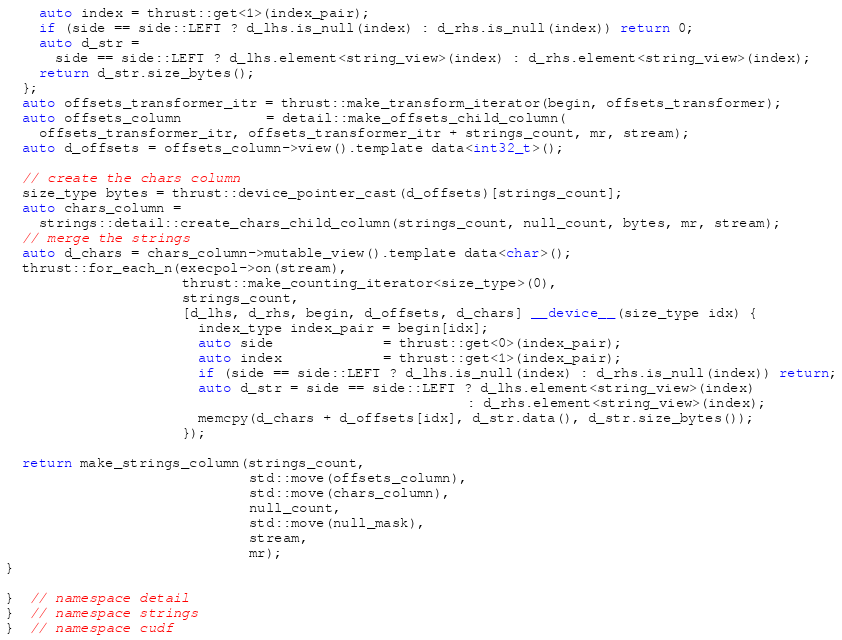Convert code to text. <code><loc_0><loc_0><loc_500><loc_500><_Cuda_>    auto index = thrust::get<1>(index_pair);
    if (side == side::LEFT ? d_lhs.is_null(index) : d_rhs.is_null(index)) return 0;
    auto d_str =
      side == side::LEFT ? d_lhs.element<string_view>(index) : d_rhs.element<string_view>(index);
    return d_str.size_bytes();
  };
  auto offsets_transformer_itr = thrust::make_transform_iterator(begin, offsets_transformer);
  auto offsets_column          = detail::make_offsets_child_column(
    offsets_transformer_itr, offsets_transformer_itr + strings_count, mr, stream);
  auto d_offsets = offsets_column->view().template data<int32_t>();

  // create the chars column
  size_type bytes = thrust::device_pointer_cast(d_offsets)[strings_count];
  auto chars_column =
    strings::detail::create_chars_child_column(strings_count, null_count, bytes, mr, stream);
  // merge the strings
  auto d_chars = chars_column->mutable_view().template data<char>();
  thrust::for_each_n(execpol->on(stream),
                     thrust::make_counting_iterator<size_type>(0),
                     strings_count,
                     [d_lhs, d_rhs, begin, d_offsets, d_chars] __device__(size_type idx) {
                       index_type index_pair = begin[idx];
                       auto side             = thrust::get<0>(index_pair);
                       auto index            = thrust::get<1>(index_pair);
                       if (side == side::LEFT ? d_lhs.is_null(index) : d_rhs.is_null(index)) return;
                       auto d_str = side == side::LEFT ? d_lhs.element<string_view>(index)
                                                       : d_rhs.element<string_view>(index);
                       memcpy(d_chars + d_offsets[idx], d_str.data(), d_str.size_bytes());
                     });

  return make_strings_column(strings_count,
                             std::move(offsets_column),
                             std::move(chars_column),
                             null_count,
                             std::move(null_mask),
                             stream,
                             mr);
}

}  // namespace detail
}  // namespace strings
}  // namespace cudf
</code> 